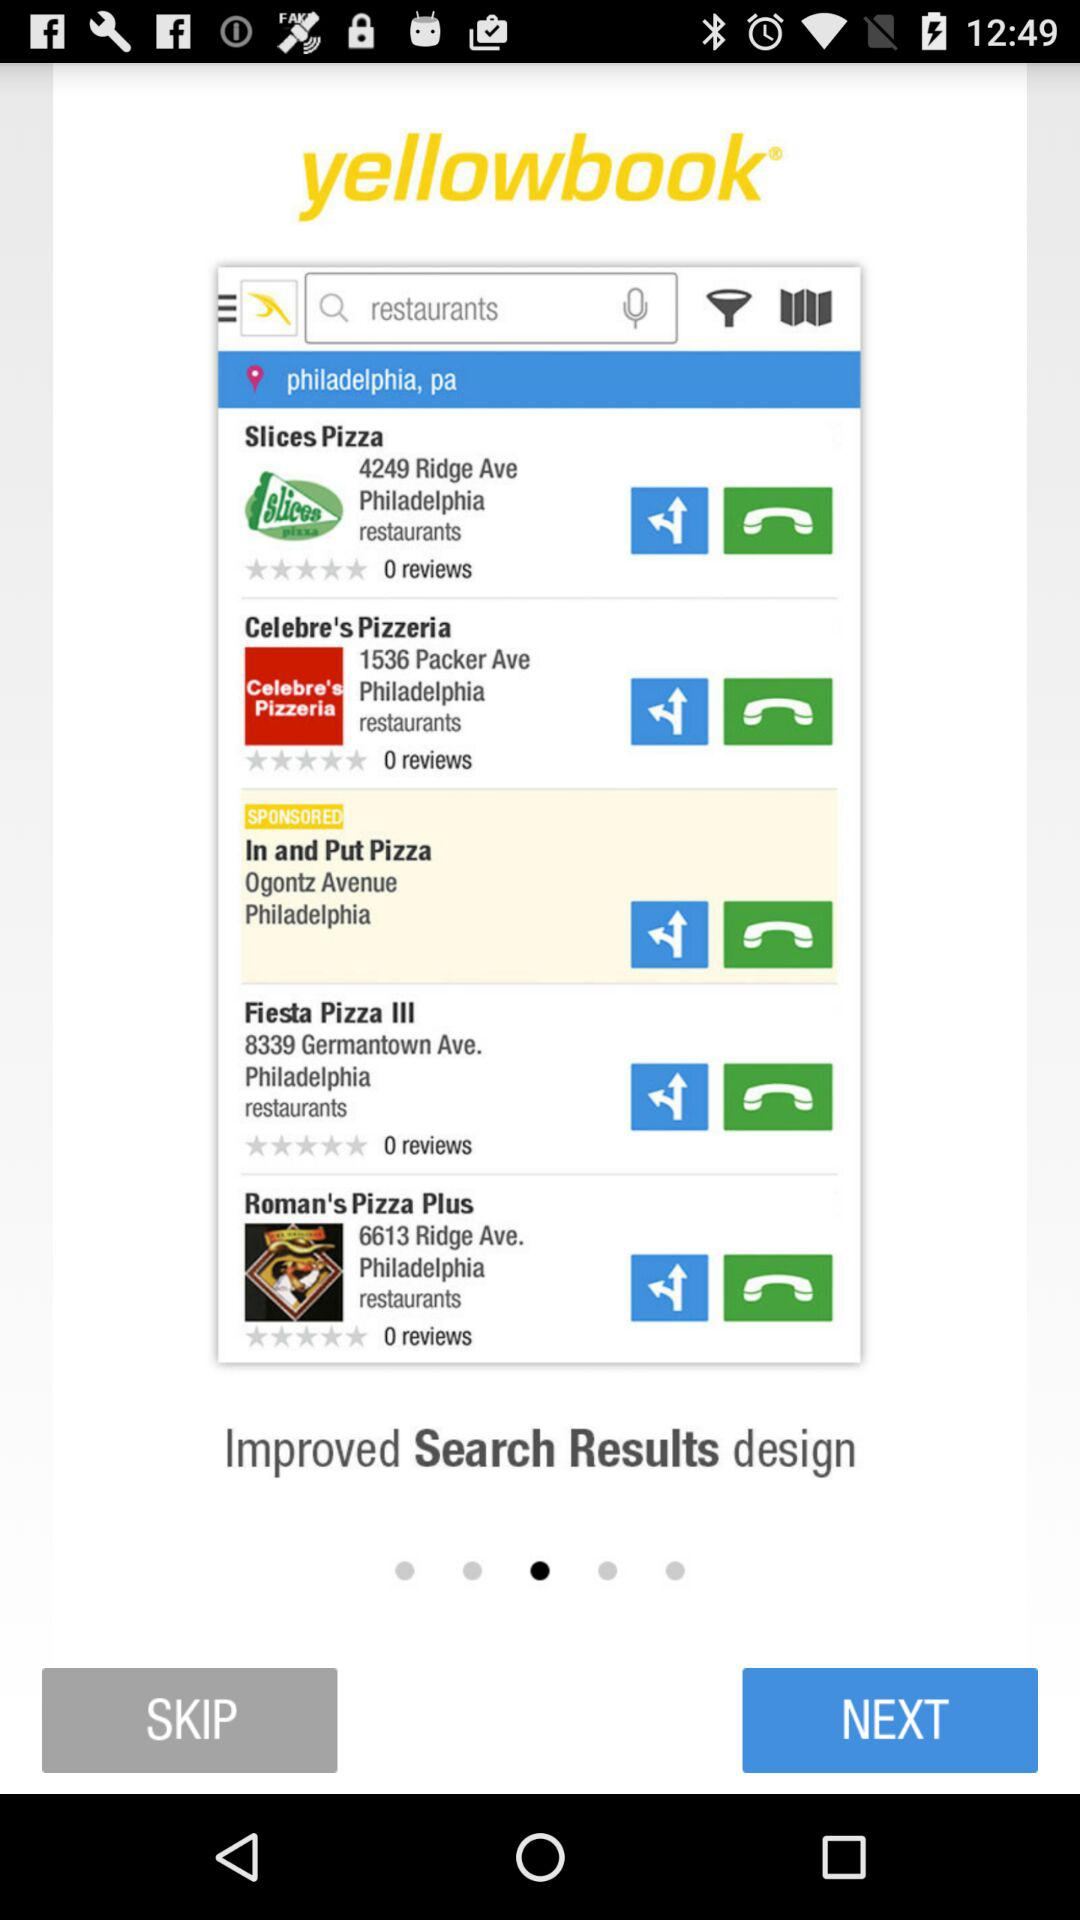What is the number of reviews of Fiesta Pizza III? The number of reviews is 0. 